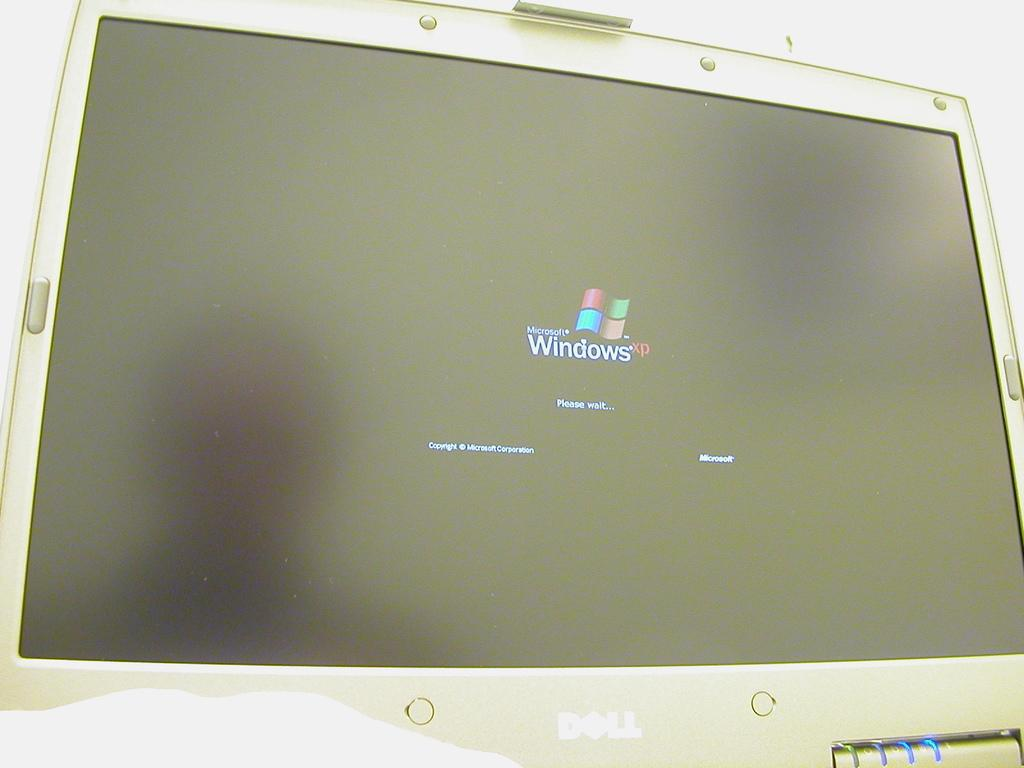<image>
Share a concise interpretation of the image provided. A computer monitor showing a Microsoft Windows XP logo saying please wait. 